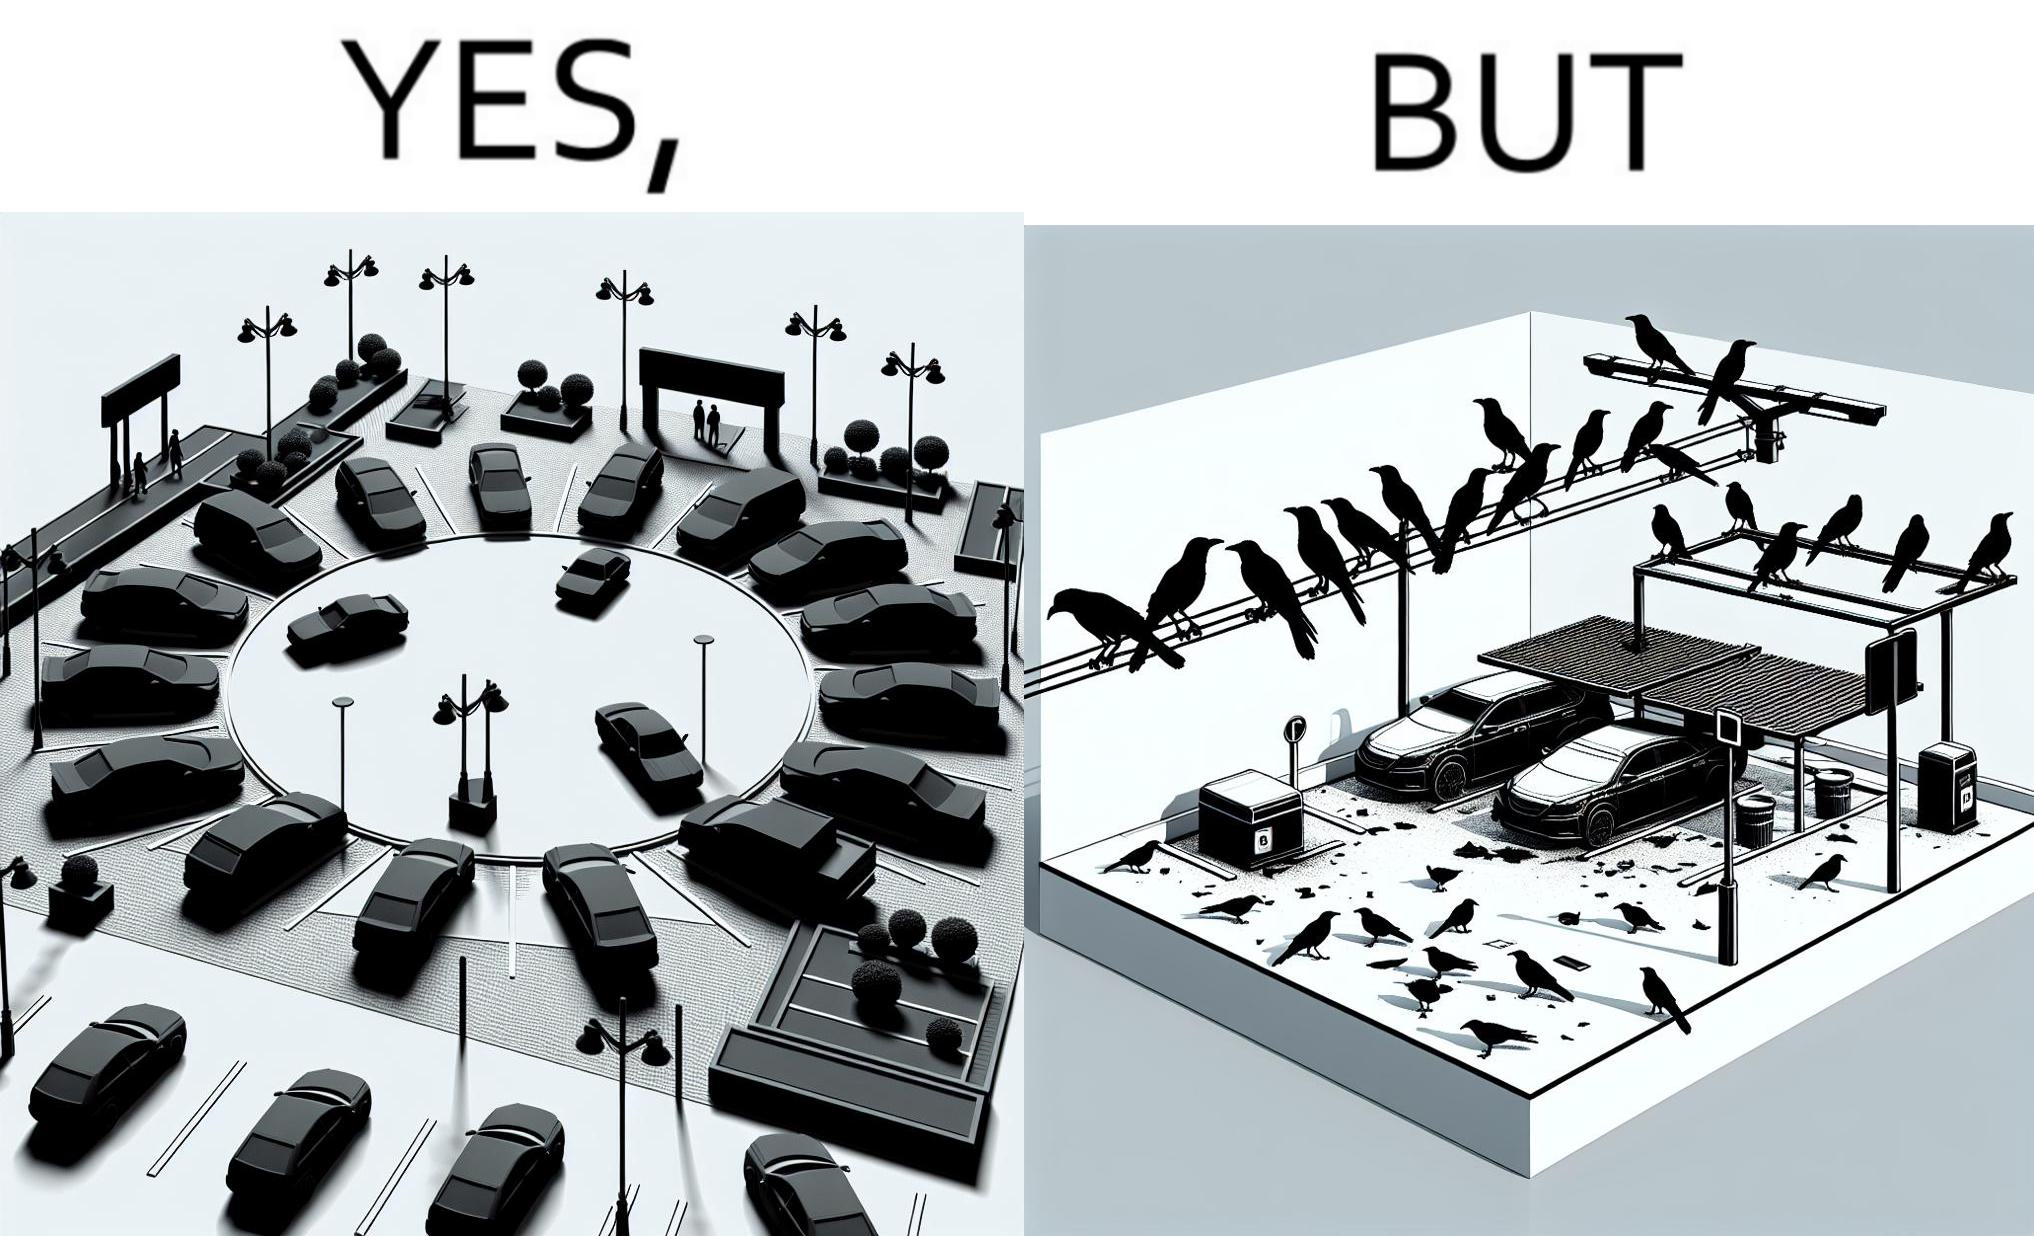What do you see in each half of this image? In the left part of the image: There is a parking place where few cars are standing leaving a place in middle. In the right part of the image: Some crows are sitting on a wire which is above the parking area and the crows are making that place dirty. 